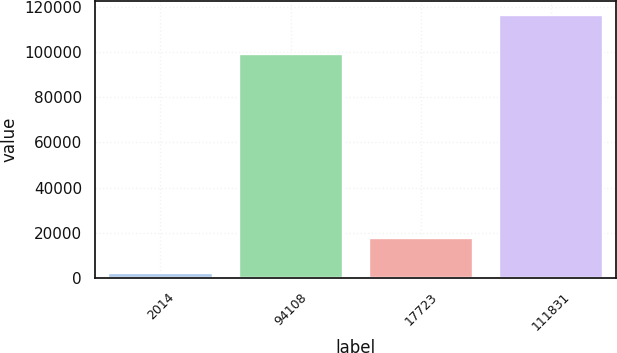<chart> <loc_0><loc_0><loc_500><loc_500><bar_chart><fcel>2014<fcel>94108<fcel>17723<fcel>111831<nl><fcel>2013<fcel>99174<fcel>17560<fcel>116734<nl></chart> 